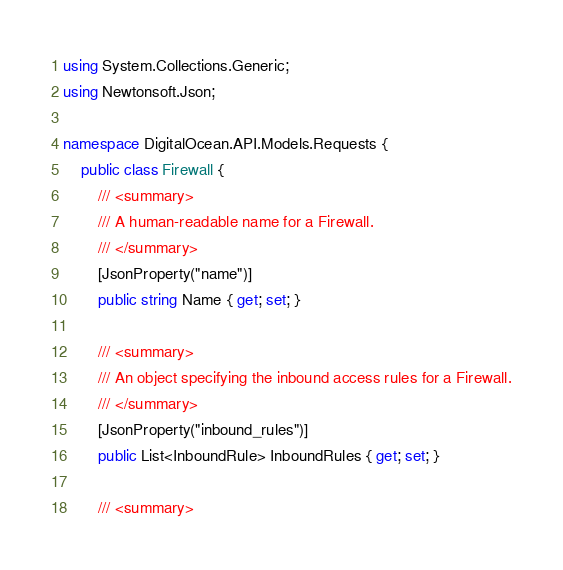Convert code to text. <code><loc_0><loc_0><loc_500><loc_500><_C#_>using System.Collections.Generic;
using Newtonsoft.Json;

namespace DigitalOcean.API.Models.Requests {
    public class Firewall {
        /// <summary>
        /// A human-readable name for a Firewall.
        /// </summary>
        [JsonProperty("name")]
        public string Name { get; set; }

        /// <summary>
        /// An object specifying the inbound access rules for a Firewall.
        /// </summary>
        [JsonProperty("inbound_rules")]
        public List<InboundRule> InboundRules { get; set; }

        /// <summary></code> 